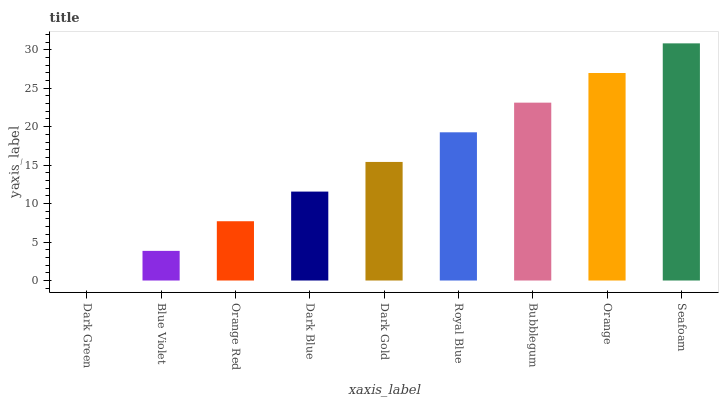Is Dark Green the minimum?
Answer yes or no. Yes. Is Seafoam the maximum?
Answer yes or no. Yes. Is Blue Violet the minimum?
Answer yes or no. No. Is Blue Violet the maximum?
Answer yes or no. No. Is Blue Violet greater than Dark Green?
Answer yes or no. Yes. Is Dark Green less than Blue Violet?
Answer yes or no. Yes. Is Dark Green greater than Blue Violet?
Answer yes or no. No. Is Blue Violet less than Dark Green?
Answer yes or no. No. Is Dark Gold the high median?
Answer yes or no. Yes. Is Dark Gold the low median?
Answer yes or no. Yes. Is Seafoam the high median?
Answer yes or no. No. Is Bubblegum the low median?
Answer yes or no. No. 